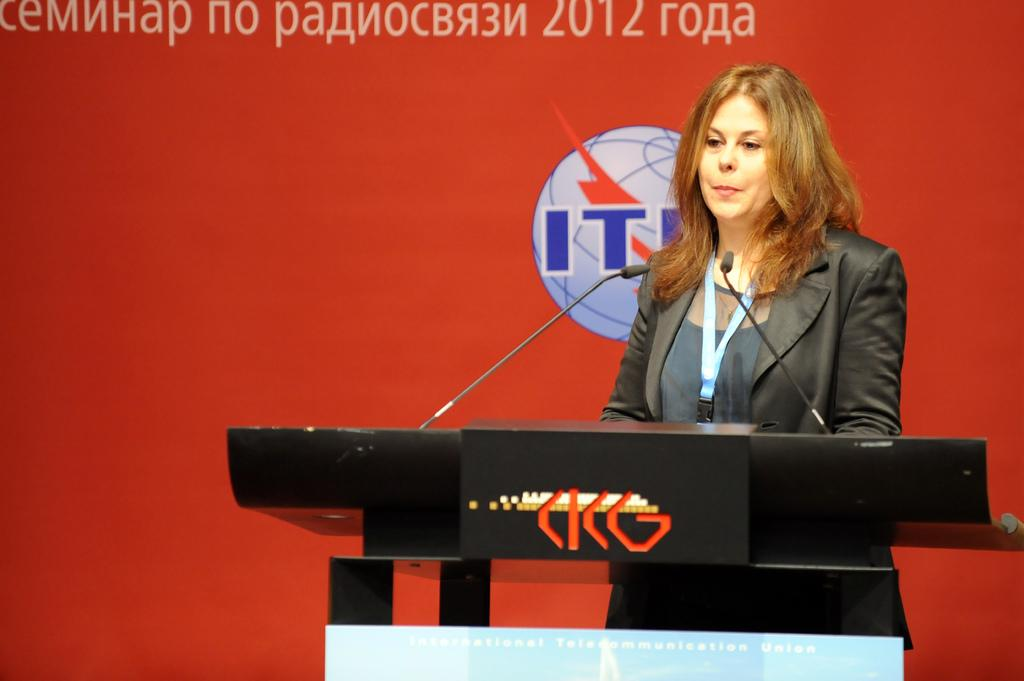What is the lady in the image doing? The lady is standing behind a podium in the image. What is on the podium that the lady is standing behind? The podium has a logo and some text on it. How many microphones are on the podium? There are two microphones on the podium. What can be seen behind the lady? There is a poster behind the lady. What is on the poster? The poster contains some text and has a logo on it. What direction is the lady's attention focused on in the image? The image does not provide information about the direction of the lady's attention, so it cannot be determined from the image. 